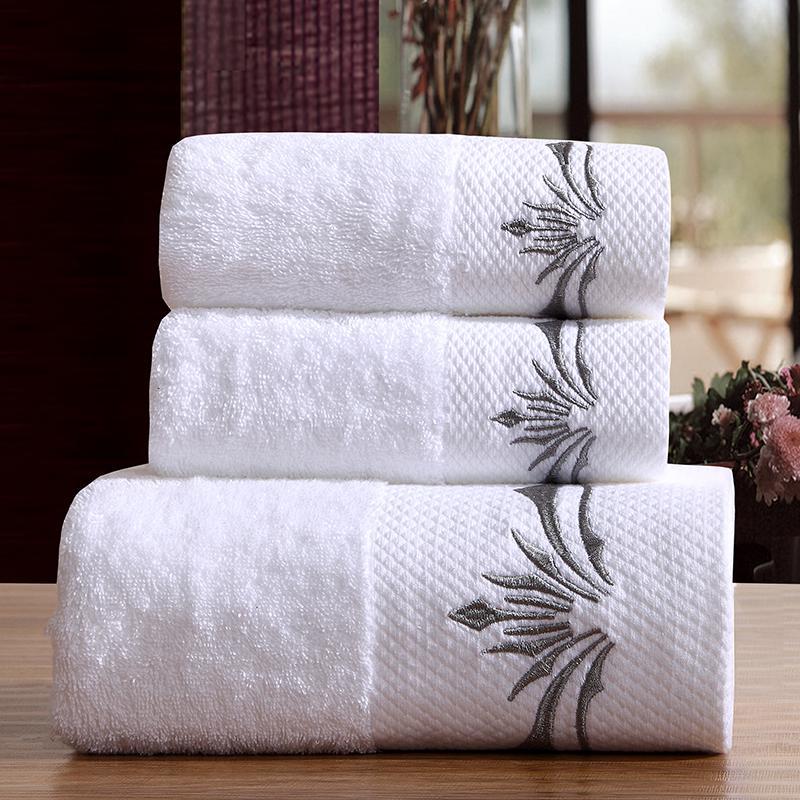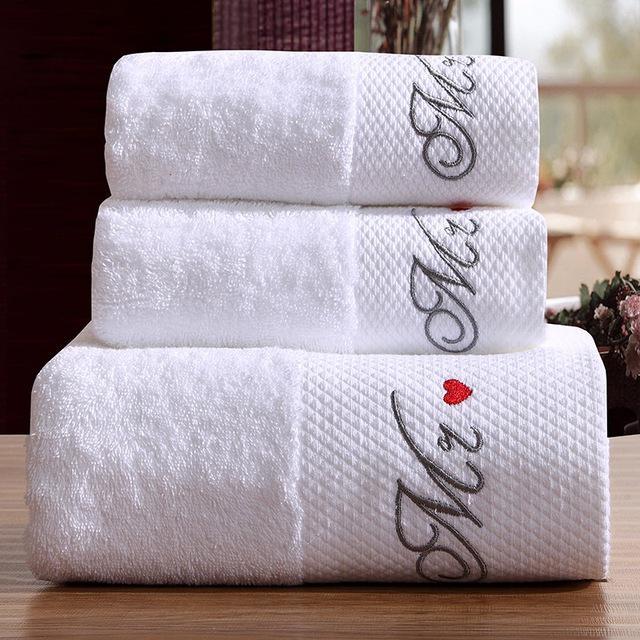The first image is the image on the left, the second image is the image on the right. For the images displayed, is the sentence "Both images contain a stack of three white towels with embroidery on the bottom." factually correct? Answer yes or no. Yes. 